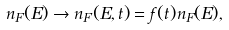Convert formula to latex. <formula><loc_0><loc_0><loc_500><loc_500>n _ { F } ( E ) \rightarrow n _ { F } ( E , t ) = f ( t ) n _ { F } ( E ) ,</formula> 